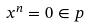<formula> <loc_0><loc_0><loc_500><loc_500>x ^ { n } = 0 \in p</formula> 